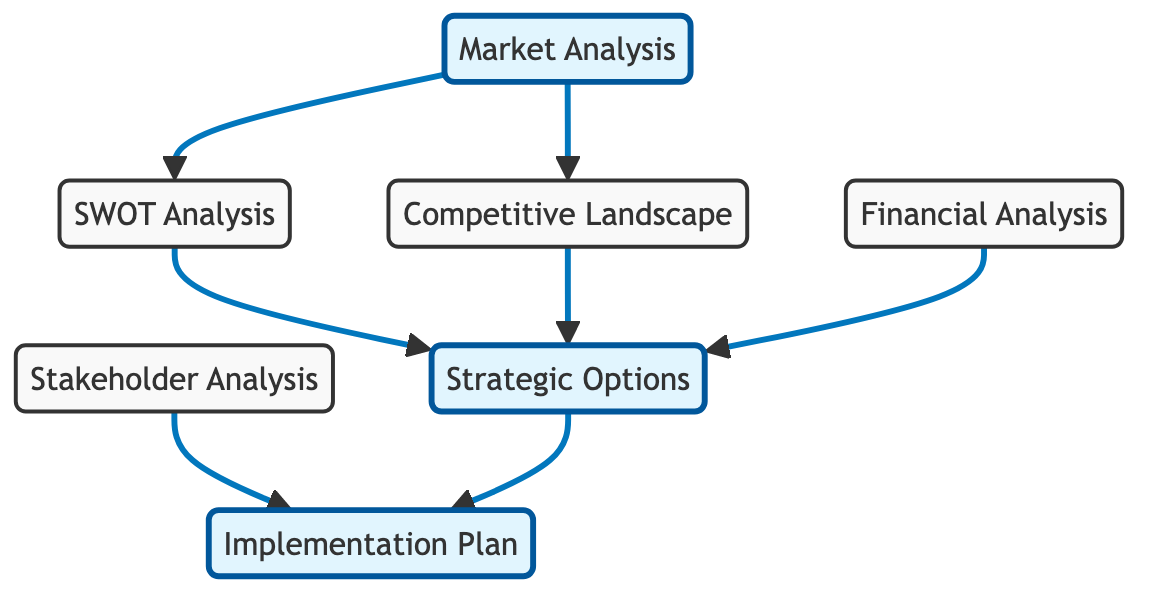What are the main components in the diagram? The main components are: Market Analysis, SWOT Analysis, Competitive Landscape, Financial Analysis, Stakeholder Analysis, Strategic Options, and Implementation Plan. These are the nodes represented in the diagram.
Answer: Market Analysis, SWOT Analysis, Competitive Landscape, Financial Analysis, Stakeholder Analysis, Strategic Options, Implementation Plan How many edges are present in the graph? By counting the connections between the nodes, there are a total of 7 edges connecting the different components. Each edge represents a relationship between two nodes.
Answer: 7 Which analysis leads to Strategic Options through SWOT? The SWOT Analysis directly leads to Strategic Options as indicated by the directed edge pointing from SWOT to Strategic Options. This shows that the outcomes from the SWOT Analysis inform the Strategic Options.
Answer: SWOT Analysis What is the role of Market Analysis in the context of this framework? Market Analysis serves as the starting point in the framework, providing insights that influence both the SWOT Analysis and the Competitive Landscape, which are then used to derive Strategic Options.
Answer: Starting point Which analysis informs the Implementation Plan? The Implementation Plan is informed by Stakeholder Analysis and Strategic Options, as indicated by directed edges pointing into the Implementation Plan node from these two analyses.
Answer: Stakeholder Analysis, Strategic Options How many nodes influence Strategic Options directly? Three nodes connect directly to Strategic Options: SWOT Analysis, Competitive Landscape, and Financial Analysis. Each of these analyses contributes different insights essential for determining Strategic Options.
Answer: 3 What is the first step to derive Strategic Options based on the diagram? The first step involves conducting Market Analysis, which then feeds into SWOT Analysis and Competitive Landscape, both of which are prerequisites for identifying Strategic Options.
Answer: Market Analysis Which node is influenced by Stakeholder Analysis? The Implementation Plan node is influenced by Stakeholder Analysis, as shown by the directed edge from Stakeholder Analysis to Implementation Plan. This highlights that stakeholder considerations should be evaluated when planning for implementation.
Answer: Implementation Plan 